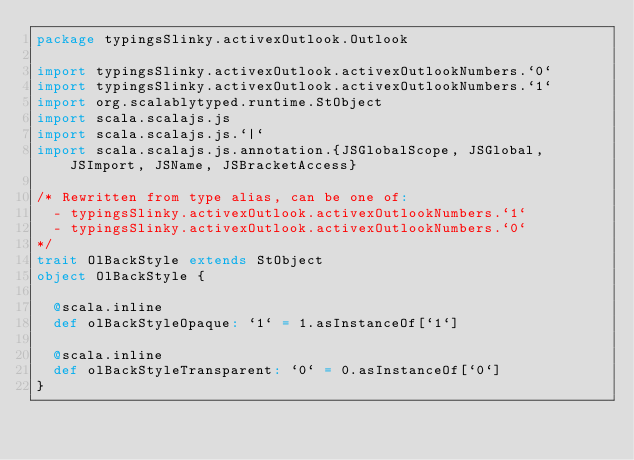<code> <loc_0><loc_0><loc_500><loc_500><_Scala_>package typingsSlinky.activexOutlook.Outlook

import typingsSlinky.activexOutlook.activexOutlookNumbers.`0`
import typingsSlinky.activexOutlook.activexOutlookNumbers.`1`
import org.scalablytyped.runtime.StObject
import scala.scalajs.js
import scala.scalajs.js.`|`
import scala.scalajs.js.annotation.{JSGlobalScope, JSGlobal, JSImport, JSName, JSBracketAccess}

/* Rewritten from type alias, can be one of: 
  - typingsSlinky.activexOutlook.activexOutlookNumbers.`1`
  - typingsSlinky.activexOutlook.activexOutlookNumbers.`0`
*/
trait OlBackStyle extends StObject
object OlBackStyle {
  
  @scala.inline
  def olBackStyleOpaque: `1` = 1.asInstanceOf[`1`]
  
  @scala.inline
  def olBackStyleTransparent: `0` = 0.asInstanceOf[`0`]
}
</code> 